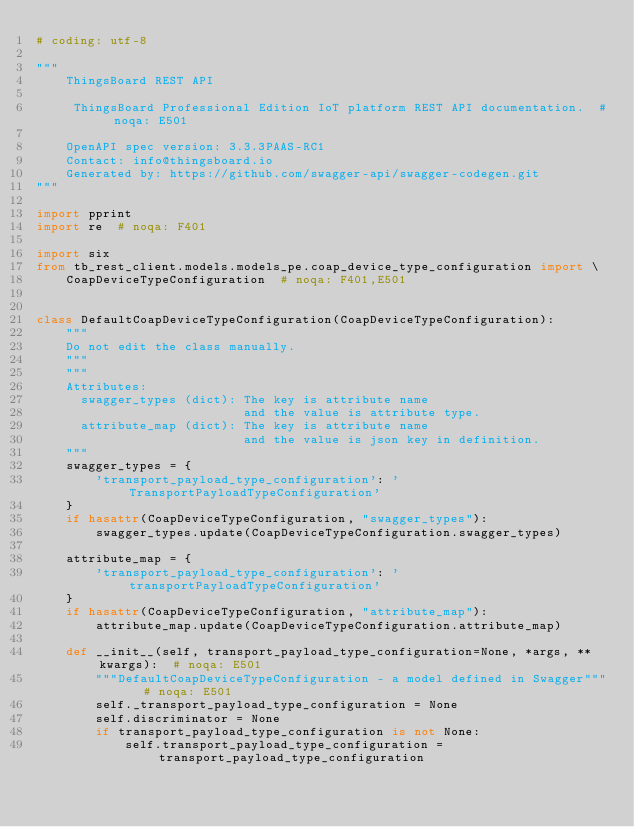<code> <loc_0><loc_0><loc_500><loc_500><_Python_># coding: utf-8

"""
    ThingsBoard REST API

     ThingsBoard Professional Edition IoT platform REST API documentation.  # noqa: E501

    OpenAPI spec version: 3.3.3PAAS-RC1
    Contact: info@thingsboard.io
    Generated by: https://github.com/swagger-api/swagger-codegen.git
"""

import pprint
import re  # noqa: F401

import six
from tb_rest_client.models.models_pe.coap_device_type_configuration import \
    CoapDeviceTypeConfiguration  # noqa: F401,E501


class DefaultCoapDeviceTypeConfiguration(CoapDeviceTypeConfiguration):
    """
    Do not edit the class manually.
    """
    """
    Attributes:
      swagger_types (dict): The key is attribute name
                            and the value is attribute type.
      attribute_map (dict): The key is attribute name
                            and the value is json key in definition.
    """
    swagger_types = {
        'transport_payload_type_configuration': 'TransportPayloadTypeConfiguration'
    }
    if hasattr(CoapDeviceTypeConfiguration, "swagger_types"):
        swagger_types.update(CoapDeviceTypeConfiguration.swagger_types)

    attribute_map = {
        'transport_payload_type_configuration': 'transportPayloadTypeConfiguration'
    }
    if hasattr(CoapDeviceTypeConfiguration, "attribute_map"):
        attribute_map.update(CoapDeviceTypeConfiguration.attribute_map)

    def __init__(self, transport_payload_type_configuration=None, *args, **kwargs):  # noqa: E501
        """DefaultCoapDeviceTypeConfiguration - a model defined in Swagger"""  # noqa: E501
        self._transport_payload_type_configuration = None
        self.discriminator = None
        if transport_payload_type_configuration is not None:
            self.transport_payload_type_configuration = transport_payload_type_configuration</code> 